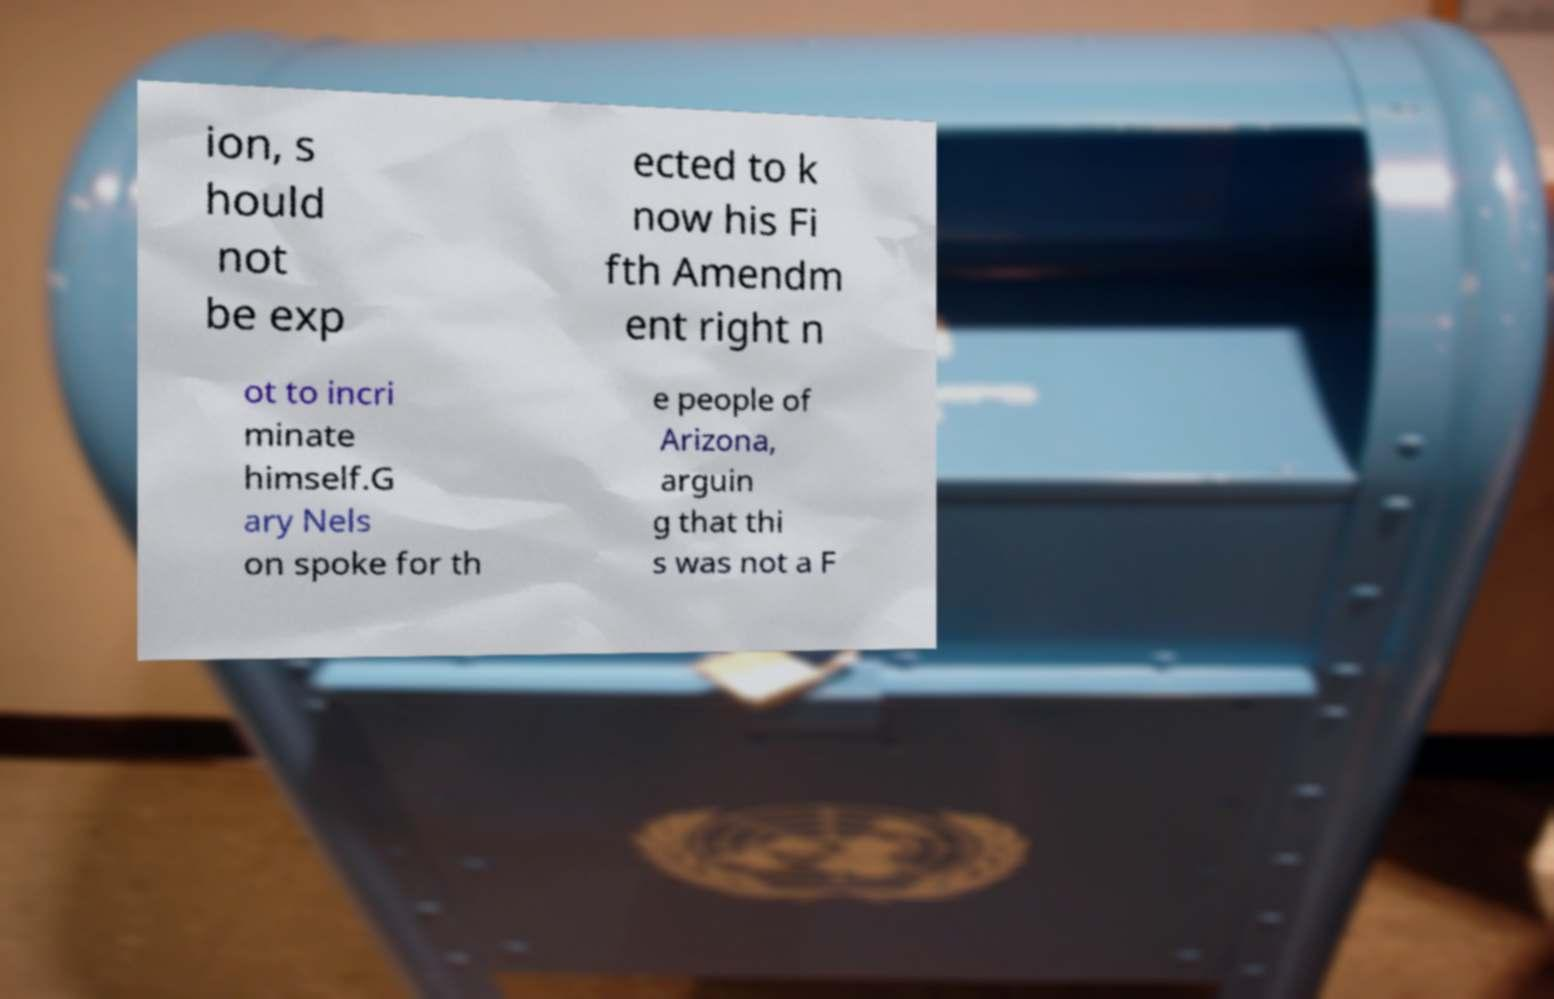For documentation purposes, I need the text within this image transcribed. Could you provide that? ion, s hould not be exp ected to k now his Fi fth Amendm ent right n ot to incri minate himself.G ary Nels on spoke for th e people of Arizona, arguin g that thi s was not a F 